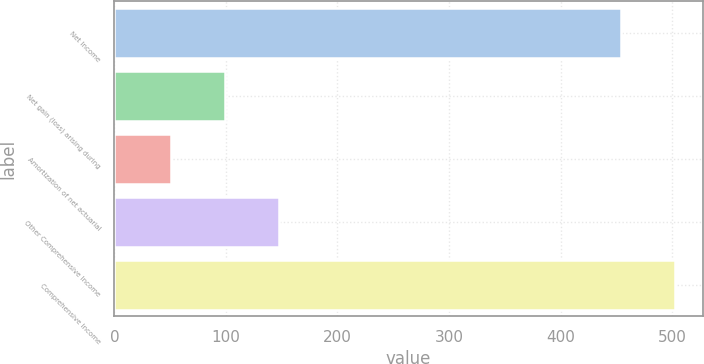<chart> <loc_0><loc_0><loc_500><loc_500><bar_chart><fcel>Net Income<fcel>Net gain (loss) arising during<fcel>Amortization of net actuarial<fcel>Other Comprehensive Income<fcel>Comprehensive Income<nl><fcel>454<fcel>99<fcel>50.5<fcel>147.5<fcel>502.5<nl></chart> 